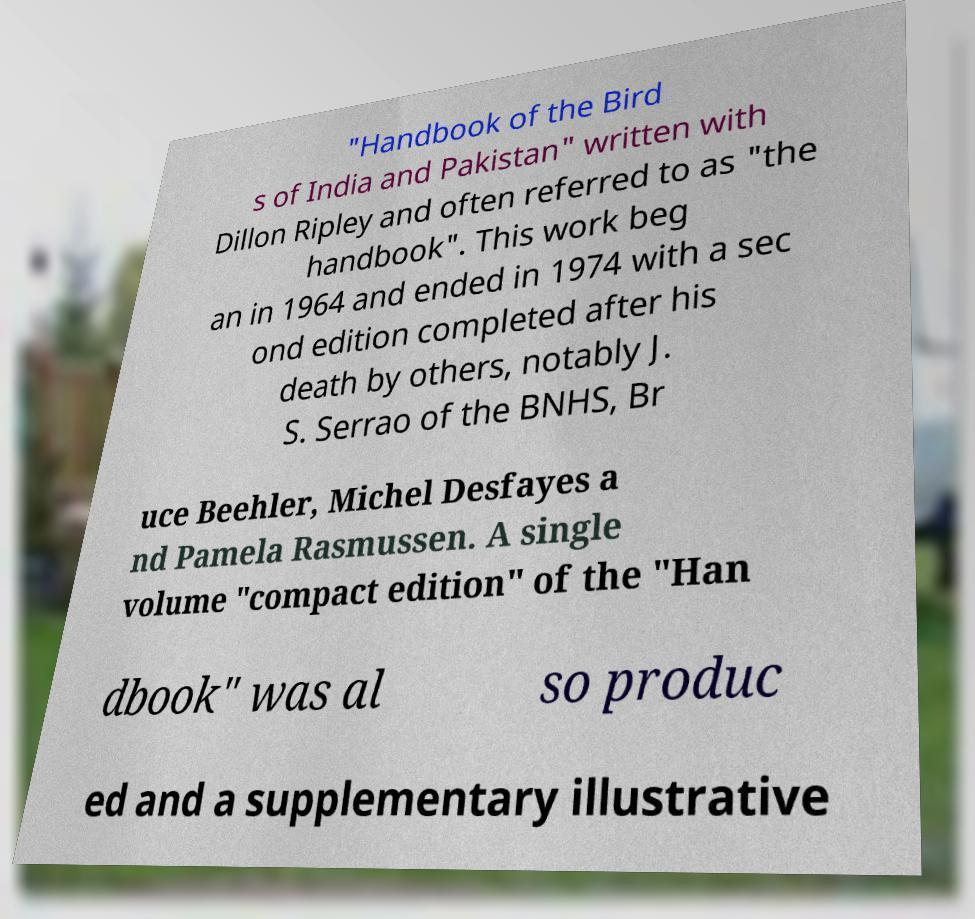Can you accurately transcribe the text from the provided image for me? "Handbook of the Bird s of India and Pakistan" written with Dillon Ripley and often referred to as "the handbook". This work beg an in 1964 and ended in 1974 with a sec ond edition completed after his death by others, notably J. S. Serrao of the BNHS, Br uce Beehler, Michel Desfayes a nd Pamela Rasmussen. A single volume "compact edition" of the "Han dbook" was al so produc ed and a supplementary illustrative 